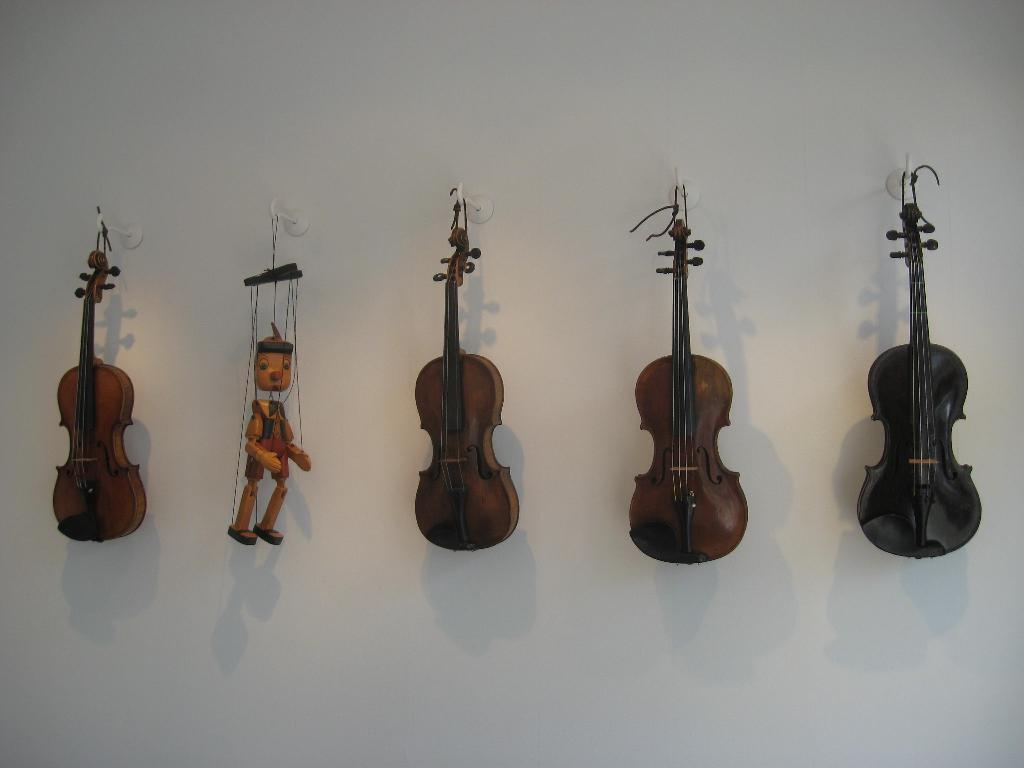What type of musical instruments are in the image? There are violins in the image. How are the violins positioned in the image? The violins are hanged on the wall. Can you describe the toy in the image? There is a toy in the left side middle of the image. What type of linen is used to cover the rabbits in the image? There are no rabbits or linen present in the image; it only features violins hanging on the wall and a toy. 